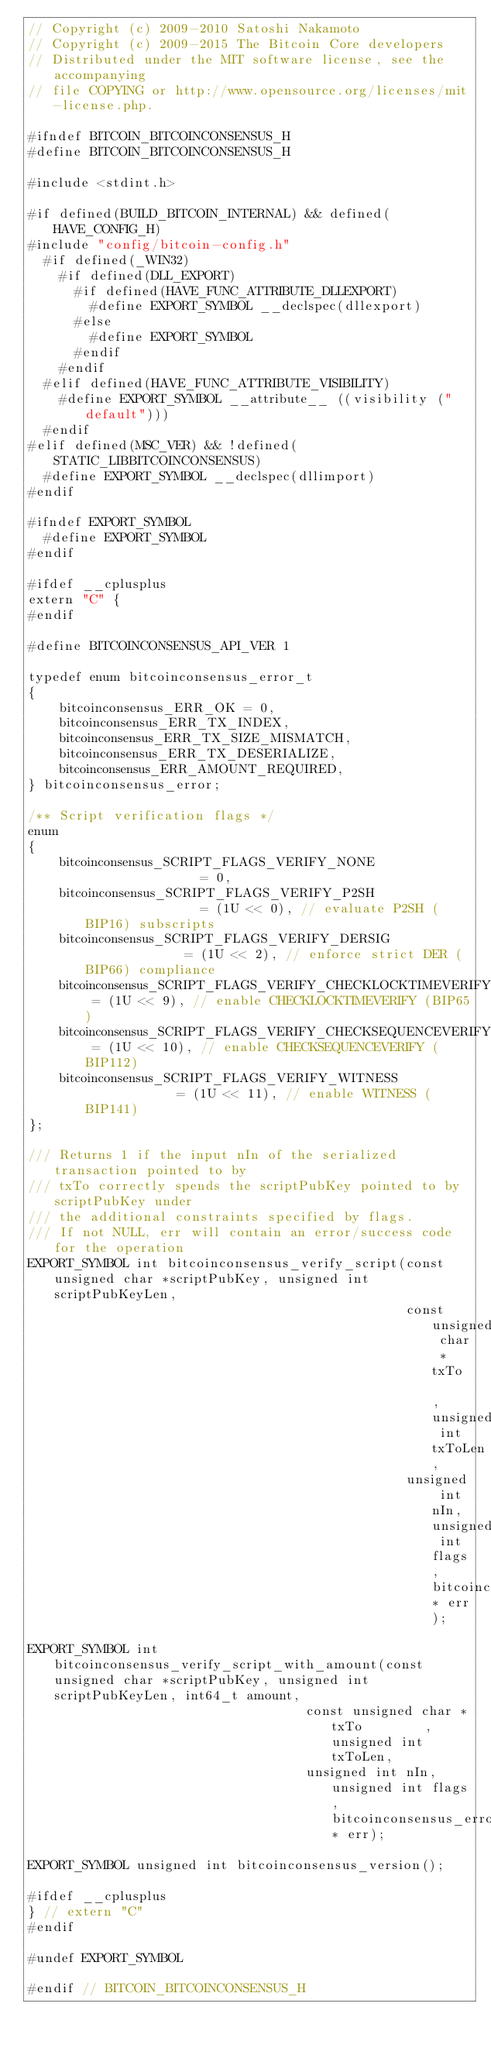Convert code to text. <code><loc_0><loc_0><loc_500><loc_500><_C_>// Copyright (c) 2009-2010 Satoshi Nakamoto
// Copyright (c) 2009-2015 The Bitcoin Core developers
// Distributed under the MIT software license, see the accompanying
// file COPYING or http://www.opensource.org/licenses/mit-license.php.

#ifndef BITCOIN_BITCOINCONSENSUS_H
#define BITCOIN_BITCOINCONSENSUS_H

#include <stdint.h>

#if defined(BUILD_BITCOIN_INTERNAL) && defined(HAVE_CONFIG_H)
#include "config/bitcoin-config.h"
  #if defined(_WIN32)
    #if defined(DLL_EXPORT)
      #if defined(HAVE_FUNC_ATTRIBUTE_DLLEXPORT)
        #define EXPORT_SYMBOL __declspec(dllexport)
      #else
        #define EXPORT_SYMBOL
      #endif
    #endif
  #elif defined(HAVE_FUNC_ATTRIBUTE_VISIBILITY)
    #define EXPORT_SYMBOL __attribute__ ((visibility ("default")))
  #endif
#elif defined(MSC_VER) && !defined(STATIC_LIBBITCOINCONSENSUS)
  #define EXPORT_SYMBOL __declspec(dllimport)
#endif

#ifndef EXPORT_SYMBOL
  #define EXPORT_SYMBOL
#endif

#ifdef __cplusplus
extern "C" {
#endif

#define BITCOINCONSENSUS_API_VER 1

typedef enum bitcoinconsensus_error_t
{
    bitcoinconsensus_ERR_OK = 0,
    bitcoinconsensus_ERR_TX_INDEX,
    bitcoinconsensus_ERR_TX_SIZE_MISMATCH,
    bitcoinconsensus_ERR_TX_DESERIALIZE,
    bitcoinconsensus_ERR_AMOUNT_REQUIRED,
} bitcoinconsensus_error;

/** Script verification flags */
enum
{
    bitcoinconsensus_SCRIPT_FLAGS_VERIFY_NONE                = 0,
    bitcoinconsensus_SCRIPT_FLAGS_VERIFY_P2SH                = (1U << 0), // evaluate P2SH (BIP16) subscripts
    bitcoinconsensus_SCRIPT_FLAGS_VERIFY_DERSIG              = (1U << 2), // enforce strict DER (BIP66) compliance
    bitcoinconsensus_SCRIPT_FLAGS_VERIFY_CHECKLOCKTIMEVERIFY = (1U << 9), // enable CHECKLOCKTIMEVERIFY (BIP65)
    bitcoinconsensus_SCRIPT_FLAGS_VERIFY_CHECKSEQUENCEVERIFY = (1U << 10), // enable CHECKSEQUENCEVERIFY (BIP112)
    bitcoinconsensus_SCRIPT_FLAGS_VERIFY_WITNESS             = (1U << 11), // enable WITNESS (BIP141)
};

/// Returns 1 if the input nIn of the serialized transaction pointed to by
/// txTo correctly spends the scriptPubKey pointed to by scriptPubKey under
/// the additional constraints specified by flags.
/// If not NULL, err will contain an error/success code for the operation
EXPORT_SYMBOL int bitcoinconsensus_verify_script(const unsigned char *scriptPubKey, unsigned int scriptPubKeyLen,
                                                 const unsigned char *txTo        , unsigned int txToLen,
                                                 unsigned int nIn, unsigned int flags, bitcoinconsensus_error* err);

EXPORT_SYMBOL int bitcoinconsensus_verify_script_with_amount(const unsigned char *scriptPubKey, unsigned int scriptPubKeyLen, int64_t amount,
                                    const unsigned char *txTo        , unsigned int txToLen,
                                    unsigned int nIn, unsigned int flags, bitcoinconsensus_error* err);

EXPORT_SYMBOL unsigned int bitcoinconsensus_version();

#ifdef __cplusplus
} // extern "C"
#endif

#undef EXPORT_SYMBOL

#endif // BITCOIN_BITCOINCONSENSUS_H
</code> 